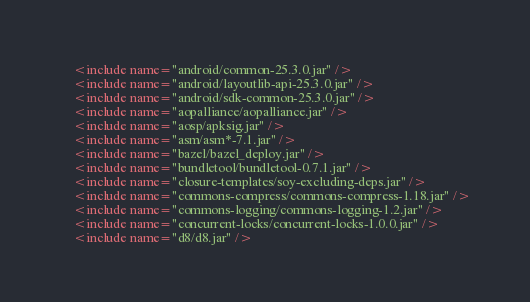Convert code to text. <code><loc_0><loc_0><loc_500><loc_500><_XML_>    <include name="android/common-25.3.0.jar" />
    <include name="android/layoutlib-api-25.3.0.jar" />
    <include name="android/sdk-common-25.3.0.jar" />
    <include name="aopalliance/aopalliance.jar" />
    <include name="aosp/apksig.jar" />
    <include name="asm/asm*-7.1.jar" />
    <include name="bazel/bazel_deploy.jar" />
    <include name="bundletool/bundletool-0.7.1.jar" />
    <include name="closure-templates/soy-excluding-deps.jar" />
    <include name="commons-compress/commons-compress-1.18.jar" />
    <include name="commons-logging/commons-logging-1.2.jar" />
    <include name="concurrent-locks/concurrent-locks-1.0.0.jar" />
    <include name="d8/d8.jar" /></code> 